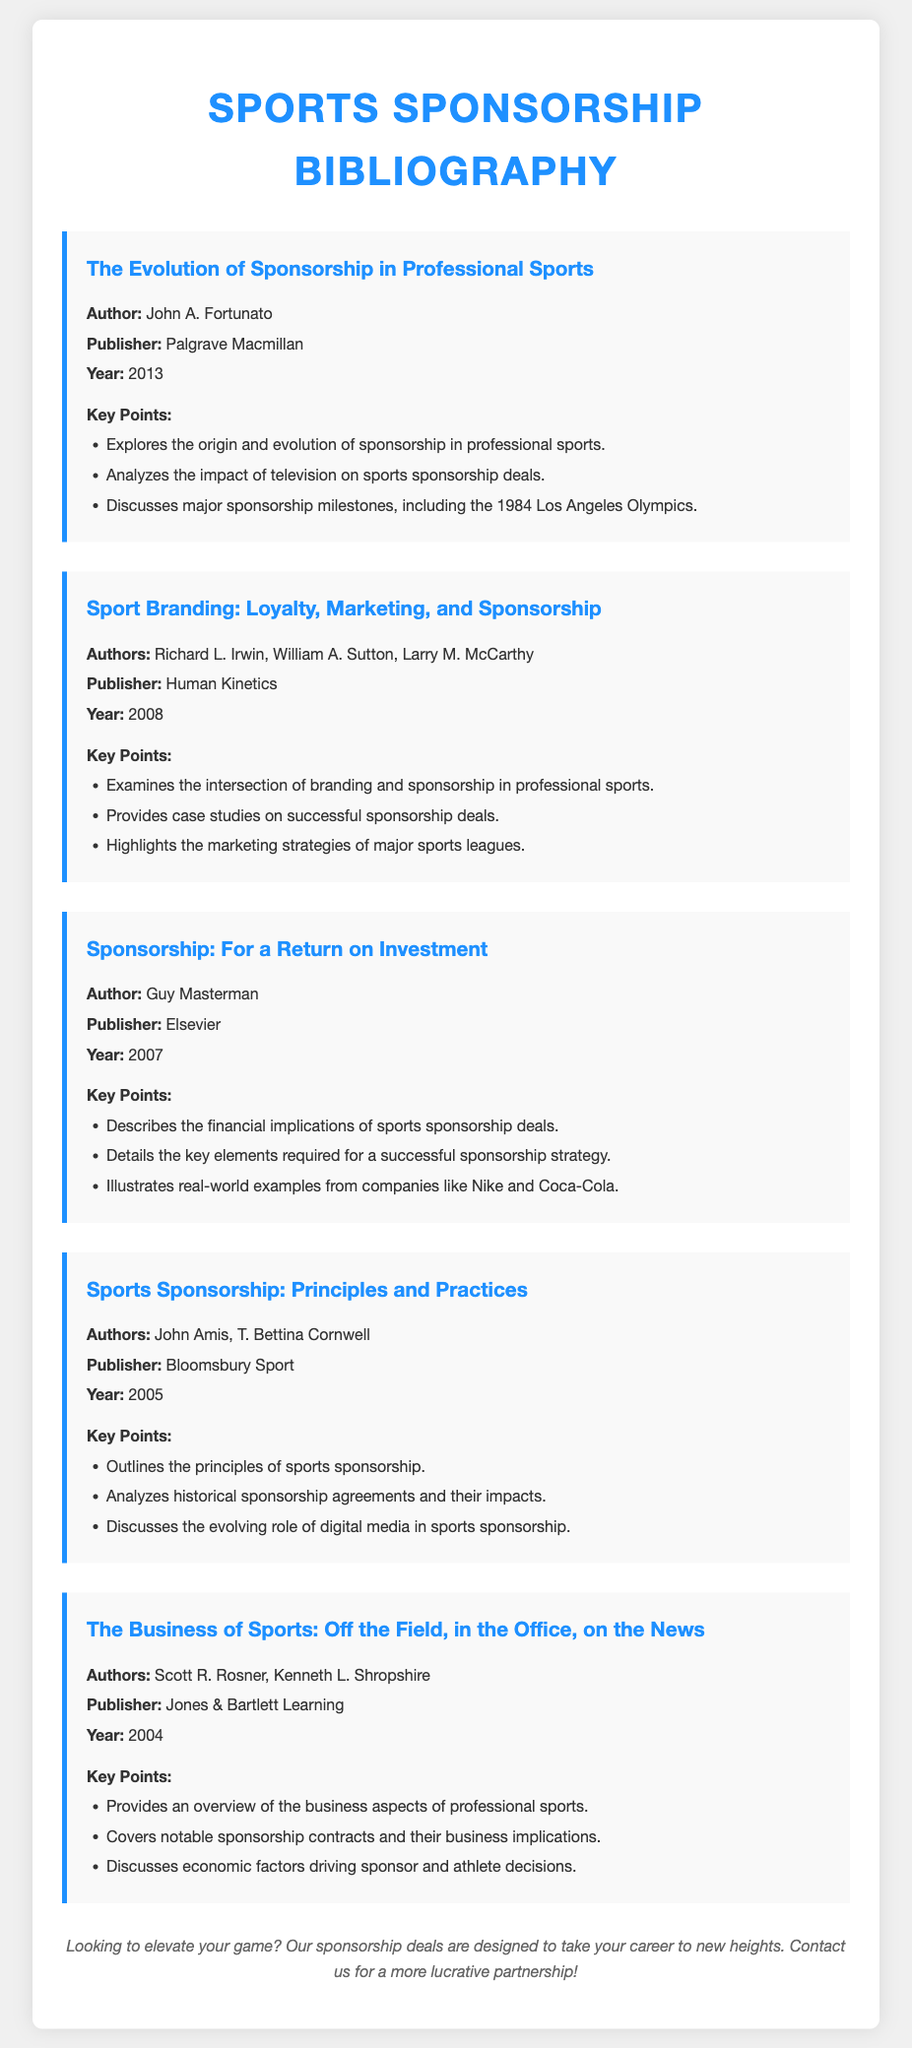What is the title of the first bibliography item? The title is the first element listed under each bibliography item, which is "The Evolution of Sponsorship in Professional Sports."
Answer: The Evolution of Sponsorship in Professional Sports Who is the author of "Sport Branding: Loyalty, Marketing, and Sponsorship"? The author is listed right after the title of the bibliography item, which is Richard L. Irwin, William A. Sutton, Larry M. McCarthy.
Answer: Richard L. Irwin, William A. Sutton, Larry M. McCarthy What year was "Sponsorship: For a Return on Investment" published? The year is stated under the publication details of the bibliography item, which is 2007.
Answer: 2007 Which publisher published "Sports Sponsorship: Principles and Practices"? The publisher is mentioned clearly under the bibliography items, which is Bloomsbury Sport.
Answer: Bloomsbury Sport How many authors contributed to "The Business of Sports: Off the Field, in the Office, on the News"? The number of authors can be found in the bibliography item, which lists Scott R. Rosner and Kenneth L. Shropshire, indicating two authors contributed.
Answer: Two What key milestone in sports sponsorship is discussed in "The Evolution of Sponsorship in Professional Sports"? The key milestone discussed is the 1984 Los Angeles Olympics.
Answer: 1984 Los Angeles Olympics What is a key focus of "Sport Branding: Loyalty, Marketing, and Sponsorship"? The focus is found in the key points section, which highlights the intersection of branding and sponsorship in professional sports.
Answer: Intersection of branding and sponsorship In what year was the "The Business of Sports: Off the Field, in the Office, on the News" published? The year is given under the publication details, which is 2004.
Answer: 2004 